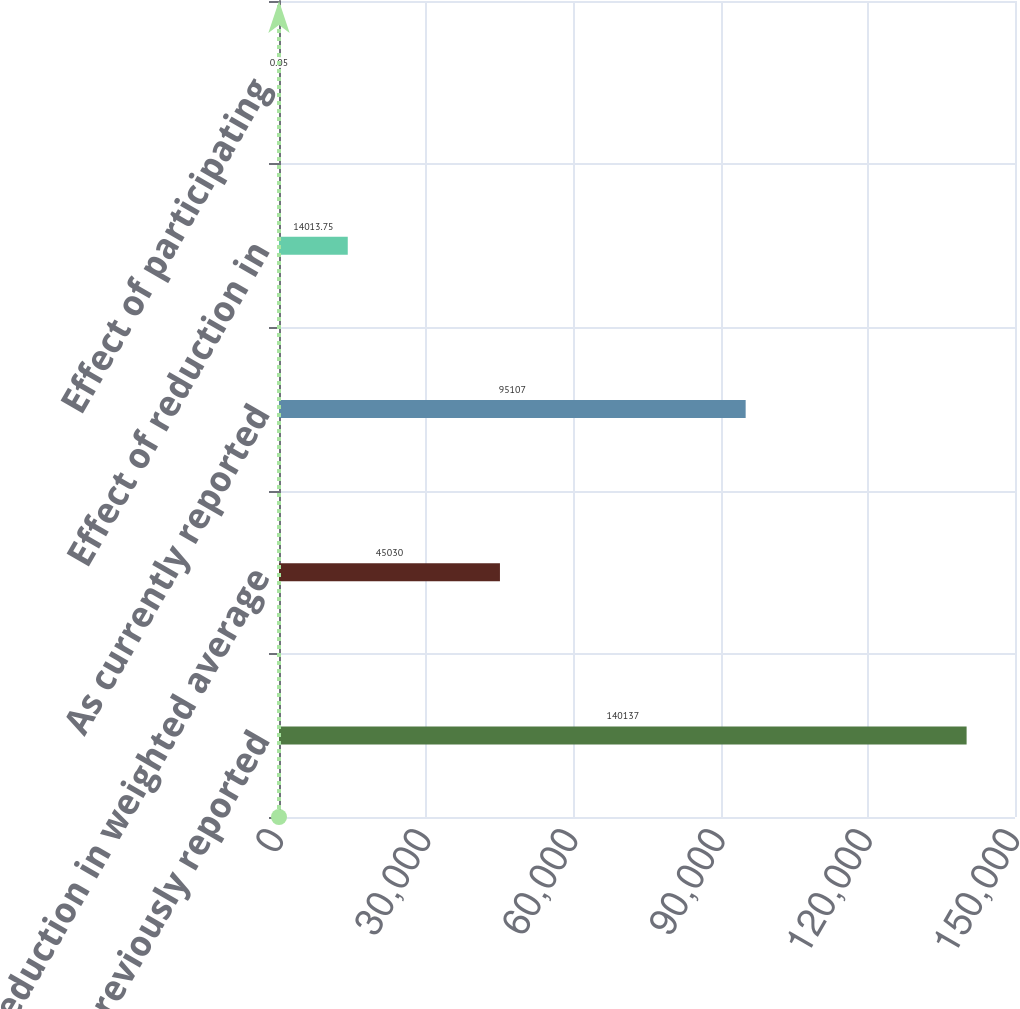<chart> <loc_0><loc_0><loc_500><loc_500><bar_chart><fcel>As previously reported<fcel>Reduction in weighted average<fcel>As currently reported<fcel>Effect of reduction in<fcel>Effect of participating<nl><fcel>140137<fcel>45030<fcel>95107<fcel>14013.8<fcel>0.05<nl></chart> 